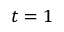Convert formula to latex. <formula><loc_0><loc_0><loc_500><loc_500>t = 1</formula> 